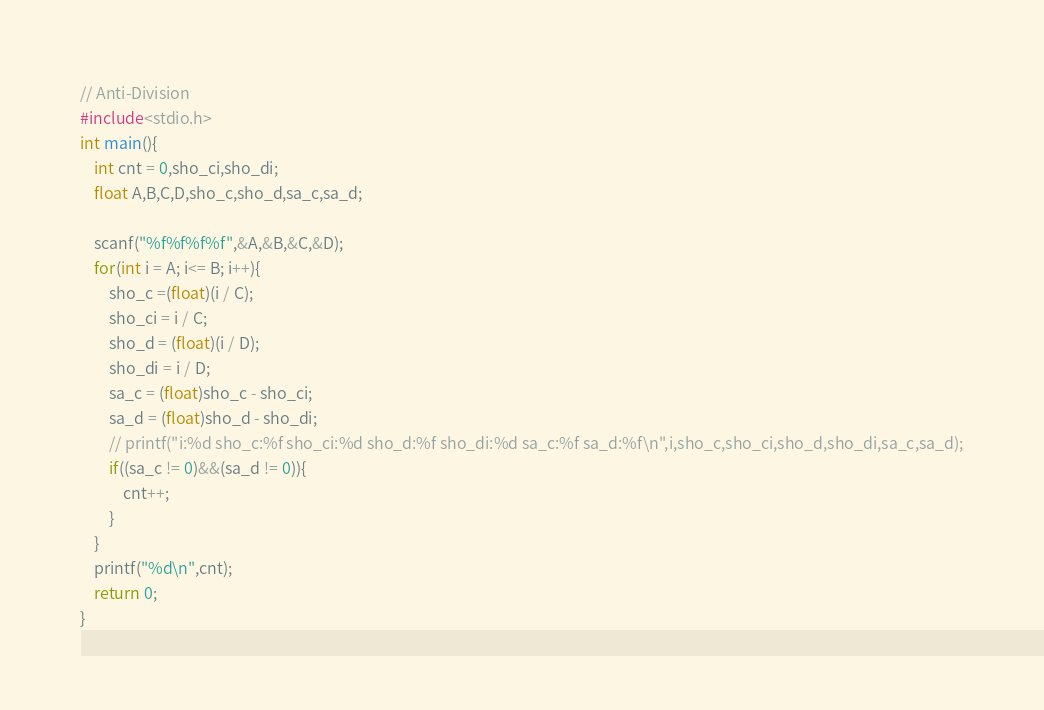<code> <loc_0><loc_0><loc_500><loc_500><_C_>// Anti-Division
#include<stdio.h>
int main(){
    int cnt = 0,sho_ci,sho_di;
    float A,B,C,D,sho_c,sho_d,sa_c,sa_d;

    scanf("%f%f%f%f",&A,&B,&C,&D);
    for(int i = A; i<= B; i++){
        sho_c =(float)(i / C);
        sho_ci = i / C;
        sho_d = (float)(i / D);
        sho_di = i / D;
        sa_c = (float)sho_c - sho_ci;
        sa_d = (float)sho_d - sho_di;
        // printf("i:%d sho_c:%f sho_ci:%d sho_d:%f sho_di:%d sa_c:%f sa_d:%f\n",i,sho_c,sho_ci,sho_d,sho_di,sa_c,sa_d);
        if((sa_c != 0)&&(sa_d != 0)){
            cnt++;
        }
    }
    printf("%d\n",cnt);
    return 0;
}</code> 